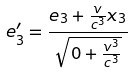<formula> <loc_0><loc_0><loc_500><loc_500>e _ { 3 } ^ { \prime } = \frac { e _ { 3 } + \frac { v } { c ^ { 3 } } x _ { 3 } } { \sqrt { 0 + \frac { v ^ { 3 } } { c ^ { 3 } } } }</formula> 